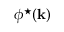Convert formula to latex. <formula><loc_0><loc_0><loc_500><loc_500>\phi ^ { ^ { * } } ( { k } )</formula> 